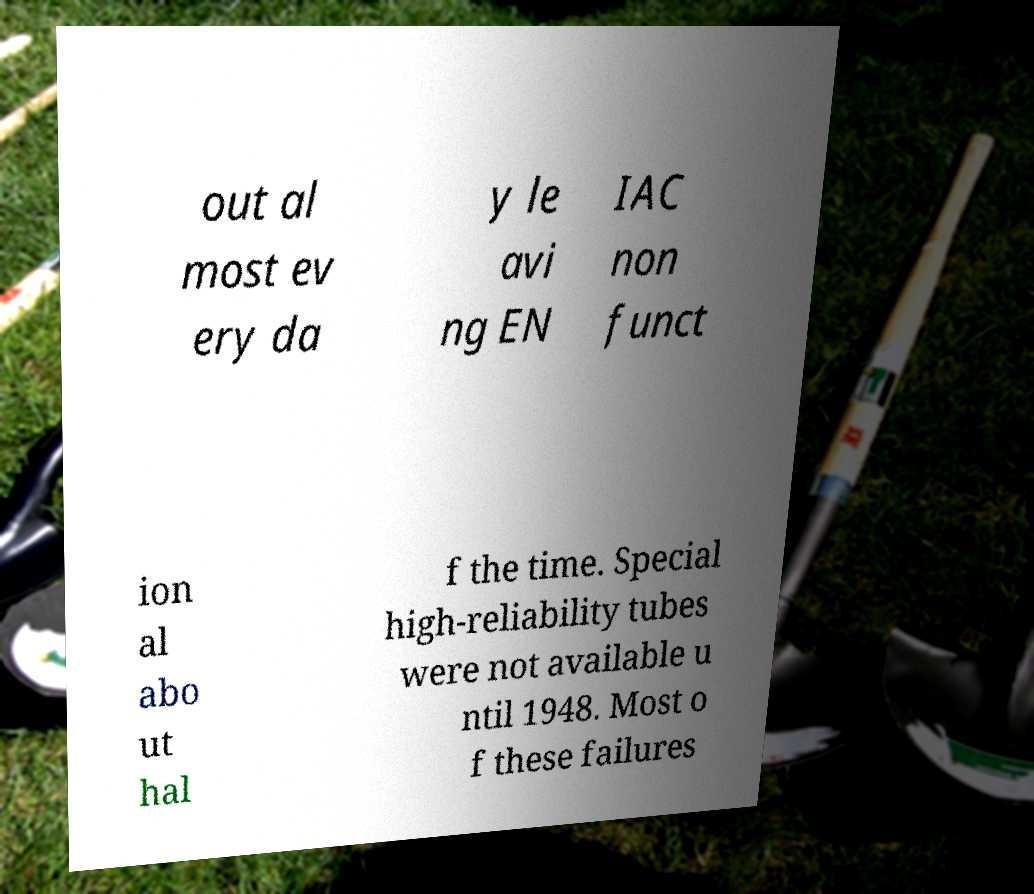What messages or text are displayed in this image? I need them in a readable, typed format. out al most ev ery da y le avi ng EN IAC non funct ion al abo ut hal f the time. Special high-reliability tubes were not available u ntil 1948. Most o f these failures 